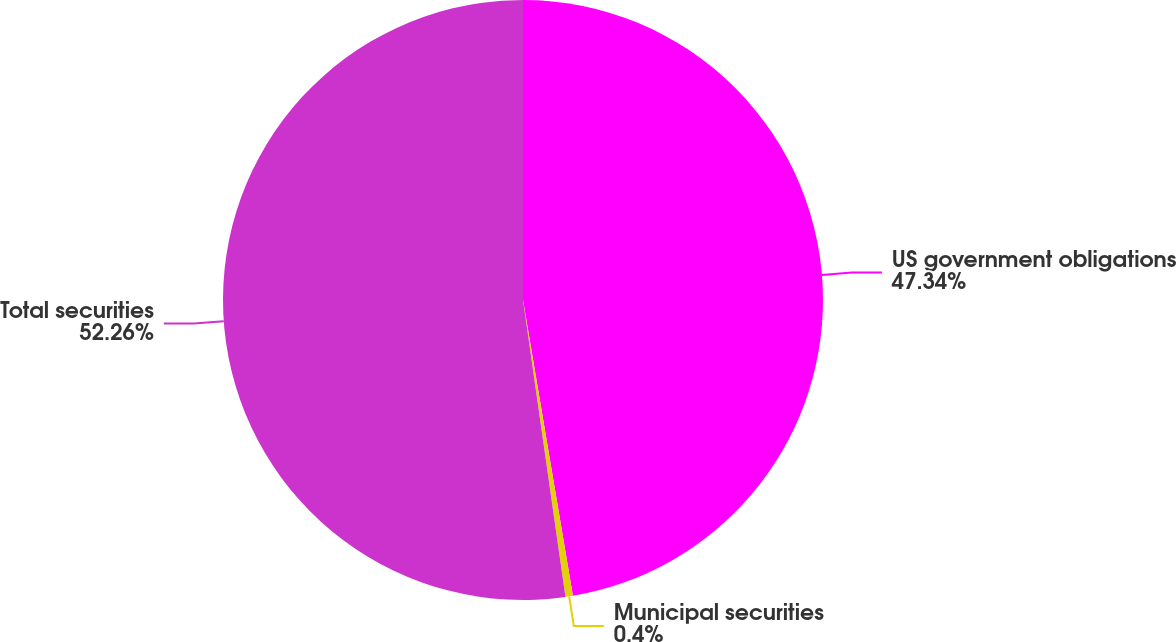Convert chart. <chart><loc_0><loc_0><loc_500><loc_500><pie_chart><fcel>US government obligations<fcel>Municipal securities<fcel>Total securities<nl><fcel>47.34%<fcel>0.4%<fcel>52.26%<nl></chart> 